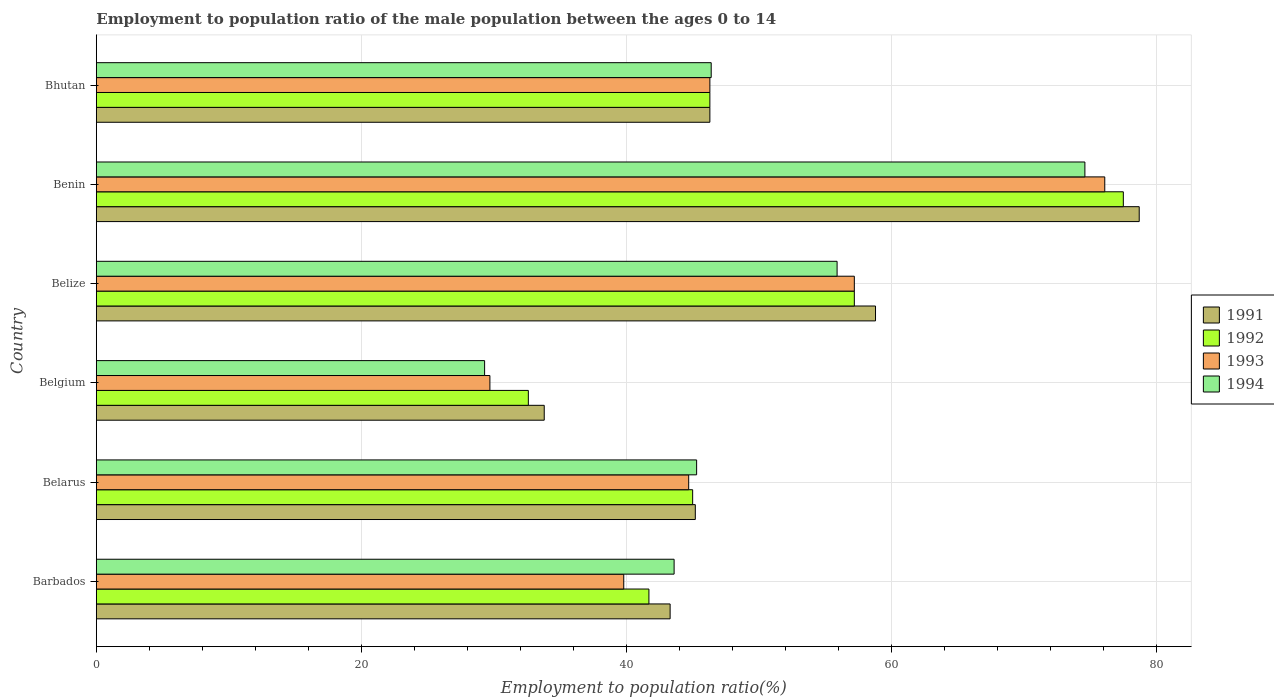Are the number of bars per tick equal to the number of legend labels?
Your response must be concise. Yes. Are the number of bars on each tick of the Y-axis equal?
Offer a terse response. Yes. How many bars are there on the 4th tick from the bottom?
Keep it short and to the point. 4. What is the label of the 2nd group of bars from the top?
Provide a succinct answer. Benin. What is the employment to population ratio in 1991 in Belgium?
Offer a very short reply. 33.8. Across all countries, what is the maximum employment to population ratio in 1992?
Your response must be concise. 77.5. Across all countries, what is the minimum employment to population ratio in 1994?
Keep it short and to the point. 29.3. In which country was the employment to population ratio in 1991 maximum?
Keep it short and to the point. Benin. In which country was the employment to population ratio in 1994 minimum?
Your answer should be compact. Belgium. What is the total employment to population ratio in 1994 in the graph?
Provide a succinct answer. 295.1. What is the difference between the employment to population ratio in 1993 in Barbados and that in Benin?
Your answer should be compact. -36.3. What is the difference between the employment to population ratio in 1992 in Belarus and the employment to population ratio in 1991 in Barbados?
Offer a terse response. 1.7. What is the average employment to population ratio in 1992 per country?
Provide a short and direct response. 50.05. What is the difference between the employment to population ratio in 1991 and employment to population ratio in 1993 in Benin?
Provide a succinct answer. 2.6. In how many countries, is the employment to population ratio in 1992 greater than 52 %?
Provide a short and direct response. 2. What is the ratio of the employment to population ratio in 1992 in Belgium to that in Belize?
Ensure brevity in your answer.  0.57. Is the employment to population ratio in 1991 in Belgium less than that in Benin?
Your answer should be very brief. Yes. Is the difference between the employment to population ratio in 1991 in Barbados and Belgium greater than the difference between the employment to population ratio in 1993 in Barbados and Belgium?
Keep it short and to the point. No. What is the difference between the highest and the second highest employment to population ratio in 1993?
Ensure brevity in your answer.  18.9. What is the difference between the highest and the lowest employment to population ratio in 1994?
Give a very brief answer. 45.3. Is it the case that in every country, the sum of the employment to population ratio in 1992 and employment to population ratio in 1993 is greater than the sum of employment to population ratio in 1991 and employment to population ratio in 1994?
Make the answer very short. No. What does the 3rd bar from the top in Barbados represents?
Keep it short and to the point. 1992. What does the 3rd bar from the bottom in Barbados represents?
Give a very brief answer. 1993. Is it the case that in every country, the sum of the employment to population ratio in 1991 and employment to population ratio in 1993 is greater than the employment to population ratio in 1994?
Offer a terse response. Yes. Are all the bars in the graph horizontal?
Give a very brief answer. Yes. Does the graph contain grids?
Your answer should be very brief. Yes. Where does the legend appear in the graph?
Your response must be concise. Center right. What is the title of the graph?
Make the answer very short. Employment to population ratio of the male population between the ages 0 to 14. What is the label or title of the X-axis?
Your answer should be very brief. Employment to population ratio(%). What is the label or title of the Y-axis?
Provide a succinct answer. Country. What is the Employment to population ratio(%) of 1991 in Barbados?
Provide a short and direct response. 43.3. What is the Employment to population ratio(%) of 1992 in Barbados?
Your answer should be very brief. 41.7. What is the Employment to population ratio(%) in 1993 in Barbados?
Make the answer very short. 39.8. What is the Employment to population ratio(%) in 1994 in Barbados?
Your answer should be very brief. 43.6. What is the Employment to population ratio(%) of 1991 in Belarus?
Keep it short and to the point. 45.2. What is the Employment to population ratio(%) in 1993 in Belarus?
Ensure brevity in your answer.  44.7. What is the Employment to population ratio(%) in 1994 in Belarus?
Provide a succinct answer. 45.3. What is the Employment to population ratio(%) of 1991 in Belgium?
Your answer should be compact. 33.8. What is the Employment to population ratio(%) of 1992 in Belgium?
Your response must be concise. 32.6. What is the Employment to population ratio(%) of 1993 in Belgium?
Make the answer very short. 29.7. What is the Employment to population ratio(%) of 1994 in Belgium?
Provide a short and direct response. 29.3. What is the Employment to population ratio(%) in 1991 in Belize?
Your answer should be very brief. 58.8. What is the Employment to population ratio(%) of 1992 in Belize?
Keep it short and to the point. 57.2. What is the Employment to population ratio(%) of 1993 in Belize?
Offer a terse response. 57.2. What is the Employment to population ratio(%) of 1994 in Belize?
Ensure brevity in your answer.  55.9. What is the Employment to population ratio(%) of 1991 in Benin?
Offer a very short reply. 78.7. What is the Employment to population ratio(%) of 1992 in Benin?
Ensure brevity in your answer.  77.5. What is the Employment to population ratio(%) in 1993 in Benin?
Your response must be concise. 76.1. What is the Employment to population ratio(%) in 1994 in Benin?
Keep it short and to the point. 74.6. What is the Employment to population ratio(%) of 1991 in Bhutan?
Your response must be concise. 46.3. What is the Employment to population ratio(%) of 1992 in Bhutan?
Provide a succinct answer. 46.3. What is the Employment to population ratio(%) of 1993 in Bhutan?
Provide a succinct answer. 46.3. What is the Employment to population ratio(%) of 1994 in Bhutan?
Offer a very short reply. 46.4. Across all countries, what is the maximum Employment to population ratio(%) of 1991?
Your response must be concise. 78.7. Across all countries, what is the maximum Employment to population ratio(%) of 1992?
Your answer should be compact. 77.5. Across all countries, what is the maximum Employment to population ratio(%) of 1993?
Offer a very short reply. 76.1. Across all countries, what is the maximum Employment to population ratio(%) in 1994?
Provide a succinct answer. 74.6. Across all countries, what is the minimum Employment to population ratio(%) in 1991?
Ensure brevity in your answer.  33.8. Across all countries, what is the minimum Employment to population ratio(%) of 1992?
Keep it short and to the point. 32.6. Across all countries, what is the minimum Employment to population ratio(%) in 1993?
Give a very brief answer. 29.7. Across all countries, what is the minimum Employment to population ratio(%) of 1994?
Make the answer very short. 29.3. What is the total Employment to population ratio(%) of 1991 in the graph?
Provide a succinct answer. 306.1. What is the total Employment to population ratio(%) in 1992 in the graph?
Provide a succinct answer. 300.3. What is the total Employment to population ratio(%) of 1993 in the graph?
Give a very brief answer. 293.8. What is the total Employment to population ratio(%) in 1994 in the graph?
Provide a succinct answer. 295.1. What is the difference between the Employment to population ratio(%) in 1991 in Barbados and that in Belarus?
Provide a succinct answer. -1.9. What is the difference between the Employment to population ratio(%) in 1993 in Barbados and that in Belarus?
Your response must be concise. -4.9. What is the difference between the Employment to population ratio(%) in 1994 in Barbados and that in Belarus?
Your response must be concise. -1.7. What is the difference between the Employment to population ratio(%) in 1992 in Barbados and that in Belgium?
Give a very brief answer. 9.1. What is the difference between the Employment to population ratio(%) in 1991 in Barbados and that in Belize?
Offer a terse response. -15.5. What is the difference between the Employment to population ratio(%) of 1992 in Barbados and that in Belize?
Provide a short and direct response. -15.5. What is the difference between the Employment to population ratio(%) of 1993 in Barbados and that in Belize?
Keep it short and to the point. -17.4. What is the difference between the Employment to population ratio(%) in 1991 in Barbados and that in Benin?
Offer a terse response. -35.4. What is the difference between the Employment to population ratio(%) in 1992 in Barbados and that in Benin?
Make the answer very short. -35.8. What is the difference between the Employment to population ratio(%) of 1993 in Barbados and that in Benin?
Offer a terse response. -36.3. What is the difference between the Employment to population ratio(%) of 1994 in Barbados and that in Benin?
Provide a succinct answer. -31. What is the difference between the Employment to population ratio(%) of 1991 in Barbados and that in Bhutan?
Your response must be concise. -3. What is the difference between the Employment to population ratio(%) in 1993 in Barbados and that in Bhutan?
Your answer should be compact. -6.5. What is the difference between the Employment to population ratio(%) of 1994 in Barbados and that in Bhutan?
Give a very brief answer. -2.8. What is the difference between the Employment to population ratio(%) in 1991 in Belarus and that in Belgium?
Make the answer very short. 11.4. What is the difference between the Employment to population ratio(%) of 1994 in Belarus and that in Belgium?
Your answer should be very brief. 16. What is the difference between the Employment to population ratio(%) of 1991 in Belarus and that in Belize?
Your response must be concise. -13.6. What is the difference between the Employment to population ratio(%) of 1993 in Belarus and that in Belize?
Make the answer very short. -12.5. What is the difference between the Employment to population ratio(%) in 1991 in Belarus and that in Benin?
Provide a short and direct response. -33.5. What is the difference between the Employment to population ratio(%) of 1992 in Belarus and that in Benin?
Offer a very short reply. -32.5. What is the difference between the Employment to population ratio(%) of 1993 in Belarus and that in Benin?
Make the answer very short. -31.4. What is the difference between the Employment to population ratio(%) of 1994 in Belarus and that in Benin?
Make the answer very short. -29.3. What is the difference between the Employment to population ratio(%) in 1991 in Belarus and that in Bhutan?
Your answer should be compact. -1.1. What is the difference between the Employment to population ratio(%) in 1993 in Belarus and that in Bhutan?
Provide a short and direct response. -1.6. What is the difference between the Employment to population ratio(%) of 1994 in Belarus and that in Bhutan?
Ensure brevity in your answer.  -1.1. What is the difference between the Employment to population ratio(%) of 1992 in Belgium and that in Belize?
Offer a terse response. -24.6. What is the difference between the Employment to population ratio(%) in 1993 in Belgium and that in Belize?
Give a very brief answer. -27.5. What is the difference between the Employment to population ratio(%) in 1994 in Belgium and that in Belize?
Keep it short and to the point. -26.6. What is the difference between the Employment to population ratio(%) of 1991 in Belgium and that in Benin?
Provide a succinct answer. -44.9. What is the difference between the Employment to population ratio(%) of 1992 in Belgium and that in Benin?
Provide a succinct answer. -44.9. What is the difference between the Employment to population ratio(%) of 1993 in Belgium and that in Benin?
Provide a short and direct response. -46.4. What is the difference between the Employment to population ratio(%) of 1994 in Belgium and that in Benin?
Provide a succinct answer. -45.3. What is the difference between the Employment to population ratio(%) in 1992 in Belgium and that in Bhutan?
Offer a very short reply. -13.7. What is the difference between the Employment to population ratio(%) in 1993 in Belgium and that in Bhutan?
Ensure brevity in your answer.  -16.6. What is the difference between the Employment to population ratio(%) of 1994 in Belgium and that in Bhutan?
Your response must be concise. -17.1. What is the difference between the Employment to population ratio(%) in 1991 in Belize and that in Benin?
Give a very brief answer. -19.9. What is the difference between the Employment to population ratio(%) in 1992 in Belize and that in Benin?
Make the answer very short. -20.3. What is the difference between the Employment to population ratio(%) of 1993 in Belize and that in Benin?
Make the answer very short. -18.9. What is the difference between the Employment to population ratio(%) of 1994 in Belize and that in Benin?
Keep it short and to the point. -18.7. What is the difference between the Employment to population ratio(%) of 1991 in Belize and that in Bhutan?
Ensure brevity in your answer.  12.5. What is the difference between the Employment to population ratio(%) in 1992 in Belize and that in Bhutan?
Give a very brief answer. 10.9. What is the difference between the Employment to population ratio(%) of 1994 in Belize and that in Bhutan?
Keep it short and to the point. 9.5. What is the difference between the Employment to population ratio(%) of 1991 in Benin and that in Bhutan?
Provide a short and direct response. 32.4. What is the difference between the Employment to population ratio(%) of 1992 in Benin and that in Bhutan?
Provide a short and direct response. 31.2. What is the difference between the Employment to population ratio(%) in 1993 in Benin and that in Bhutan?
Keep it short and to the point. 29.8. What is the difference between the Employment to population ratio(%) of 1994 in Benin and that in Bhutan?
Your answer should be very brief. 28.2. What is the difference between the Employment to population ratio(%) in 1991 in Barbados and the Employment to population ratio(%) in 1992 in Belarus?
Ensure brevity in your answer.  -1.7. What is the difference between the Employment to population ratio(%) in 1991 in Barbados and the Employment to population ratio(%) in 1994 in Belarus?
Keep it short and to the point. -2. What is the difference between the Employment to population ratio(%) in 1993 in Barbados and the Employment to population ratio(%) in 1994 in Belarus?
Your answer should be very brief. -5.5. What is the difference between the Employment to population ratio(%) of 1992 in Barbados and the Employment to population ratio(%) of 1994 in Belgium?
Ensure brevity in your answer.  12.4. What is the difference between the Employment to population ratio(%) of 1991 in Barbados and the Employment to population ratio(%) of 1992 in Belize?
Your answer should be very brief. -13.9. What is the difference between the Employment to population ratio(%) in 1991 in Barbados and the Employment to population ratio(%) in 1994 in Belize?
Give a very brief answer. -12.6. What is the difference between the Employment to population ratio(%) of 1992 in Barbados and the Employment to population ratio(%) of 1993 in Belize?
Your answer should be very brief. -15.5. What is the difference between the Employment to population ratio(%) in 1992 in Barbados and the Employment to population ratio(%) in 1994 in Belize?
Ensure brevity in your answer.  -14.2. What is the difference between the Employment to population ratio(%) in 1993 in Barbados and the Employment to population ratio(%) in 1994 in Belize?
Give a very brief answer. -16.1. What is the difference between the Employment to population ratio(%) in 1991 in Barbados and the Employment to population ratio(%) in 1992 in Benin?
Ensure brevity in your answer.  -34.2. What is the difference between the Employment to population ratio(%) in 1991 in Barbados and the Employment to population ratio(%) in 1993 in Benin?
Provide a succinct answer. -32.8. What is the difference between the Employment to population ratio(%) in 1991 in Barbados and the Employment to population ratio(%) in 1994 in Benin?
Give a very brief answer. -31.3. What is the difference between the Employment to population ratio(%) in 1992 in Barbados and the Employment to population ratio(%) in 1993 in Benin?
Offer a terse response. -34.4. What is the difference between the Employment to population ratio(%) in 1992 in Barbados and the Employment to population ratio(%) in 1994 in Benin?
Provide a short and direct response. -32.9. What is the difference between the Employment to population ratio(%) in 1993 in Barbados and the Employment to population ratio(%) in 1994 in Benin?
Your answer should be very brief. -34.8. What is the difference between the Employment to population ratio(%) in 1991 in Barbados and the Employment to population ratio(%) in 1992 in Bhutan?
Your answer should be very brief. -3. What is the difference between the Employment to population ratio(%) of 1991 in Barbados and the Employment to population ratio(%) of 1993 in Bhutan?
Keep it short and to the point. -3. What is the difference between the Employment to population ratio(%) in 1991 in Belarus and the Employment to population ratio(%) in 1993 in Belgium?
Ensure brevity in your answer.  15.5. What is the difference between the Employment to population ratio(%) of 1991 in Belarus and the Employment to population ratio(%) of 1994 in Belgium?
Offer a terse response. 15.9. What is the difference between the Employment to population ratio(%) in 1991 in Belarus and the Employment to population ratio(%) in 1993 in Belize?
Offer a very short reply. -12. What is the difference between the Employment to population ratio(%) in 1991 in Belarus and the Employment to population ratio(%) in 1994 in Belize?
Offer a terse response. -10.7. What is the difference between the Employment to population ratio(%) in 1992 in Belarus and the Employment to population ratio(%) in 1993 in Belize?
Ensure brevity in your answer.  -12.2. What is the difference between the Employment to population ratio(%) of 1992 in Belarus and the Employment to population ratio(%) of 1994 in Belize?
Keep it short and to the point. -10.9. What is the difference between the Employment to population ratio(%) of 1991 in Belarus and the Employment to population ratio(%) of 1992 in Benin?
Provide a succinct answer. -32.3. What is the difference between the Employment to population ratio(%) in 1991 in Belarus and the Employment to population ratio(%) in 1993 in Benin?
Your answer should be very brief. -30.9. What is the difference between the Employment to population ratio(%) in 1991 in Belarus and the Employment to population ratio(%) in 1994 in Benin?
Your answer should be very brief. -29.4. What is the difference between the Employment to population ratio(%) of 1992 in Belarus and the Employment to population ratio(%) of 1993 in Benin?
Make the answer very short. -31.1. What is the difference between the Employment to population ratio(%) of 1992 in Belarus and the Employment to population ratio(%) of 1994 in Benin?
Provide a short and direct response. -29.6. What is the difference between the Employment to population ratio(%) of 1993 in Belarus and the Employment to population ratio(%) of 1994 in Benin?
Offer a very short reply. -29.9. What is the difference between the Employment to population ratio(%) in 1991 in Belarus and the Employment to population ratio(%) in 1994 in Bhutan?
Make the answer very short. -1.2. What is the difference between the Employment to population ratio(%) of 1992 in Belarus and the Employment to population ratio(%) of 1994 in Bhutan?
Make the answer very short. -1.4. What is the difference between the Employment to population ratio(%) of 1993 in Belarus and the Employment to population ratio(%) of 1994 in Bhutan?
Make the answer very short. -1.7. What is the difference between the Employment to population ratio(%) in 1991 in Belgium and the Employment to population ratio(%) in 1992 in Belize?
Make the answer very short. -23.4. What is the difference between the Employment to population ratio(%) of 1991 in Belgium and the Employment to population ratio(%) of 1993 in Belize?
Provide a short and direct response. -23.4. What is the difference between the Employment to population ratio(%) in 1991 in Belgium and the Employment to population ratio(%) in 1994 in Belize?
Provide a short and direct response. -22.1. What is the difference between the Employment to population ratio(%) in 1992 in Belgium and the Employment to population ratio(%) in 1993 in Belize?
Offer a very short reply. -24.6. What is the difference between the Employment to population ratio(%) of 1992 in Belgium and the Employment to population ratio(%) of 1994 in Belize?
Give a very brief answer. -23.3. What is the difference between the Employment to population ratio(%) of 1993 in Belgium and the Employment to population ratio(%) of 1994 in Belize?
Offer a terse response. -26.2. What is the difference between the Employment to population ratio(%) in 1991 in Belgium and the Employment to population ratio(%) in 1992 in Benin?
Your answer should be very brief. -43.7. What is the difference between the Employment to population ratio(%) of 1991 in Belgium and the Employment to population ratio(%) of 1993 in Benin?
Make the answer very short. -42.3. What is the difference between the Employment to population ratio(%) of 1991 in Belgium and the Employment to population ratio(%) of 1994 in Benin?
Provide a succinct answer. -40.8. What is the difference between the Employment to population ratio(%) of 1992 in Belgium and the Employment to population ratio(%) of 1993 in Benin?
Your answer should be very brief. -43.5. What is the difference between the Employment to population ratio(%) of 1992 in Belgium and the Employment to population ratio(%) of 1994 in Benin?
Make the answer very short. -42. What is the difference between the Employment to population ratio(%) of 1993 in Belgium and the Employment to population ratio(%) of 1994 in Benin?
Your answer should be compact. -44.9. What is the difference between the Employment to population ratio(%) in 1991 in Belgium and the Employment to population ratio(%) in 1992 in Bhutan?
Make the answer very short. -12.5. What is the difference between the Employment to population ratio(%) of 1991 in Belgium and the Employment to population ratio(%) of 1993 in Bhutan?
Your answer should be very brief. -12.5. What is the difference between the Employment to population ratio(%) in 1991 in Belgium and the Employment to population ratio(%) in 1994 in Bhutan?
Provide a short and direct response. -12.6. What is the difference between the Employment to population ratio(%) in 1992 in Belgium and the Employment to population ratio(%) in 1993 in Bhutan?
Give a very brief answer. -13.7. What is the difference between the Employment to population ratio(%) in 1992 in Belgium and the Employment to population ratio(%) in 1994 in Bhutan?
Keep it short and to the point. -13.8. What is the difference between the Employment to population ratio(%) of 1993 in Belgium and the Employment to population ratio(%) of 1994 in Bhutan?
Your answer should be compact. -16.7. What is the difference between the Employment to population ratio(%) in 1991 in Belize and the Employment to population ratio(%) in 1992 in Benin?
Give a very brief answer. -18.7. What is the difference between the Employment to population ratio(%) of 1991 in Belize and the Employment to population ratio(%) of 1993 in Benin?
Make the answer very short. -17.3. What is the difference between the Employment to population ratio(%) in 1991 in Belize and the Employment to population ratio(%) in 1994 in Benin?
Offer a terse response. -15.8. What is the difference between the Employment to population ratio(%) in 1992 in Belize and the Employment to population ratio(%) in 1993 in Benin?
Give a very brief answer. -18.9. What is the difference between the Employment to population ratio(%) of 1992 in Belize and the Employment to population ratio(%) of 1994 in Benin?
Your answer should be very brief. -17.4. What is the difference between the Employment to population ratio(%) of 1993 in Belize and the Employment to population ratio(%) of 1994 in Benin?
Make the answer very short. -17.4. What is the difference between the Employment to population ratio(%) in 1991 in Belize and the Employment to population ratio(%) in 1992 in Bhutan?
Offer a terse response. 12.5. What is the difference between the Employment to population ratio(%) in 1991 in Benin and the Employment to population ratio(%) in 1992 in Bhutan?
Your answer should be very brief. 32.4. What is the difference between the Employment to population ratio(%) in 1991 in Benin and the Employment to population ratio(%) in 1993 in Bhutan?
Your response must be concise. 32.4. What is the difference between the Employment to population ratio(%) in 1991 in Benin and the Employment to population ratio(%) in 1994 in Bhutan?
Keep it short and to the point. 32.3. What is the difference between the Employment to population ratio(%) in 1992 in Benin and the Employment to population ratio(%) in 1993 in Bhutan?
Provide a short and direct response. 31.2. What is the difference between the Employment to population ratio(%) of 1992 in Benin and the Employment to population ratio(%) of 1994 in Bhutan?
Provide a succinct answer. 31.1. What is the difference between the Employment to population ratio(%) of 1993 in Benin and the Employment to population ratio(%) of 1994 in Bhutan?
Offer a terse response. 29.7. What is the average Employment to population ratio(%) in 1991 per country?
Provide a succinct answer. 51.02. What is the average Employment to population ratio(%) in 1992 per country?
Keep it short and to the point. 50.05. What is the average Employment to population ratio(%) of 1993 per country?
Provide a short and direct response. 48.97. What is the average Employment to population ratio(%) of 1994 per country?
Make the answer very short. 49.18. What is the difference between the Employment to population ratio(%) of 1991 and Employment to population ratio(%) of 1993 in Barbados?
Your response must be concise. 3.5. What is the difference between the Employment to population ratio(%) in 1993 and Employment to population ratio(%) in 1994 in Barbados?
Ensure brevity in your answer.  -3.8. What is the difference between the Employment to population ratio(%) of 1991 and Employment to population ratio(%) of 1992 in Belarus?
Ensure brevity in your answer.  0.2. What is the difference between the Employment to population ratio(%) in 1991 and Employment to population ratio(%) in 1993 in Belarus?
Ensure brevity in your answer.  0.5. What is the difference between the Employment to population ratio(%) of 1991 and Employment to population ratio(%) of 1994 in Belarus?
Give a very brief answer. -0.1. What is the difference between the Employment to population ratio(%) of 1992 and Employment to population ratio(%) of 1993 in Belarus?
Give a very brief answer. 0.3. What is the difference between the Employment to population ratio(%) in 1992 and Employment to population ratio(%) in 1994 in Belarus?
Provide a succinct answer. -0.3. What is the difference between the Employment to population ratio(%) of 1993 and Employment to population ratio(%) of 1994 in Belarus?
Provide a short and direct response. -0.6. What is the difference between the Employment to population ratio(%) in 1991 and Employment to population ratio(%) in 1993 in Belgium?
Provide a succinct answer. 4.1. What is the difference between the Employment to population ratio(%) in 1992 and Employment to population ratio(%) in 1994 in Belgium?
Ensure brevity in your answer.  3.3. What is the difference between the Employment to population ratio(%) in 1993 and Employment to population ratio(%) in 1994 in Belgium?
Provide a short and direct response. 0.4. What is the difference between the Employment to population ratio(%) of 1991 and Employment to population ratio(%) of 1993 in Belize?
Keep it short and to the point. 1.6. What is the difference between the Employment to population ratio(%) of 1991 and Employment to population ratio(%) of 1994 in Belize?
Provide a short and direct response. 2.9. What is the difference between the Employment to population ratio(%) in 1992 and Employment to population ratio(%) in 1994 in Belize?
Provide a short and direct response. 1.3. What is the difference between the Employment to population ratio(%) in 1993 and Employment to population ratio(%) in 1994 in Belize?
Provide a succinct answer. 1.3. What is the difference between the Employment to population ratio(%) of 1992 and Employment to population ratio(%) of 1993 in Bhutan?
Ensure brevity in your answer.  0. What is the difference between the Employment to population ratio(%) of 1992 and Employment to population ratio(%) of 1994 in Bhutan?
Offer a terse response. -0.1. What is the ratio of the Employment to population ratio(%) in 1991 in Barbados to that in Belarus?
Your response must be concise. 0.96. What is the ratio of the Employment to population ratio(%) of 1992 in Barbados to that in Belarus?
Offer a very short reply. 0.93. What is the ratio of the Employment to population ratio(%) in 1993 in Barbados to that in Belarus?
Offer a very short reply. 0.89. What is the ratio of the Employment to population ratio(%) in 1994 in Barbados to that in Belarus?
Keep it short and to the point. 0.96. What is the ratio of the Employment to population ratio(%) in 1991 in Barbados to that in Belgium?
Your answer should be very brief. 1.28. What is the ratio of the Employment to population ratio(%) of 1992 in Barbados to that in Belgium?
Keep it short and to the point. 1.28. What is the ratio of the Employment to population ratio(%) in 1993 in Barbados to that in Belgium?
Make the answer very short. 1.34. What is the ratio of the Employment to population ratio(%) of 1994 in Barbados to that in Belgium?
Your response must be concise. 1.49. What is the ratio of the Employment to population ratio(%) of 1991 in Barbados to that in Belize?
Ensure brevity in your answer.  0.74. What is the ratio of the Employment to population ratio(%) of 1992 in Barbados to that in Belize?
Make the answer very short. 0.73. What is the ratio of the Employment to population ratio(%) in 1993 in Barbados to that in Belize?
Provide a succinct answer. 0.7. What is the ratio of the Employment to population ratio(%) of 1994 in Barbados to that in Belize?
Your response must be concise. 0.78. What is the ratio of the Employment to population ratio(%) in 1991 in Barbados to that in Benin?
Your response must be concise. 0.55. What is the ratio of the Employment to population ratio(%) of 1992 in Barbados to that in Benin?
Provide a short and direct response. 0.54. What is the ratio of the Employment to population ratio(%) in 1993 in Barbados to that in Benin?
Give a very brief answer. 0.52. What is the ratio of the Employment to population ratio(%) of 1994 in Barbados to that in Benin?
Your answer should be very brief. 0.58. What is the ratio of the Employment to population ratio(%) of 1991 in Barbados to that in Bhutan?
Your response must be concise. 0.94. What is the ratio of the Employment to population ratio(%) of 1992 in Barbados to that in Bhutan?
Ensure brevity in your answer.  0.9. What is the ratio of the Employment to population ratio(%) of 1993 in Barbados to that in Bhutan?
Ensure brevity in your answer.  0.86. What is the ratio of the Employment to population ratio(%) in 1994 in Barbados to that in Bhutan?
Your answer should be very brief. 0.94. What is the ratio of the Employment to population ratio(%) in 1991 in Belarus to that in Belgium?
Offer a terse response. 1.34. What is the ratio of the Employment to population ratio(%) in 1992 in Belarus to that in Belgium?
Provide a short and direct response. 1.38. What is the ratio of the Employment to population ratio(%) of 1993 in Belarus to that in Belgium?
Your answer should be compact. 1.51. What is the ratio of the Employment to population ratio(%) in 1994 in Belarus to that in Belgium?
Give a very brief answer. 1.55. What is the ratio of the Employment to population ratio(%) of 1991 in Belarus to that in Belize?
Ensure brevity in your answer.  0.77. What is the ratio of the Employment to population ratio(%) in 1992 in Belarus to that in Belize?
Provide a short and direct response. 0.79. What is the ratio of the Employment to population ratio(%) of 1993 in Belarus to that in Belize?
Provide a short and direct response. 0.78. What is the ratio of the Employment to population ratio(%) of 1994 in Belarus to that in Belize?
Offer a terse response. 0.81. What is the ratio of the Employment to population ratio(%) of 1991 in Belarus to that in Benin?
Your answer should be compact. 0.57. What is the ratio of the Employment to population ratio(%) in 1992 in Belarus to that in Benin?
Make the answer very short. 0.58. What is the ratio of the Employment to population ratio(%) in 1993 in Belarus to that in Benin?
Provide a short and direct response. 0.59. What is the ratio of the Employment to population ratio(%) of 1994 in Belarus to that in Benin?
Your answer should be very brief. 0.61. What is the ratio of the Employment to population ratio(%) in 1991 in Belarus to that in Bhutan?
Your answer should be compact. 0.98. What is the ratio of the Employment to population ratio(%) of 1992 in Belarus to that in Bhutan?
Keep it short and to the point. 0.97. What is the ratio of the Employment to population ratio(%) in 1993 in Belarus to that in Bhutan?
Provide a succinct answer. 0.97. What is the ratio of the Employment to population ratio(%) in 1994 in Belarus to that in Bhutan?
Make the answer very short. 0.98. What is the ratio of the Employment to population ratio(%) of 1991 in Belgium to that in Belize?
Make the answer very short. 0.57. What is the ratio of the Employment to population ratio(%) in 1992 in Belgium to that in Belize?
Your answer should be very brief. 0.57. What is the ratio of the Employment to population ratio(%) in 1993 in Belgium to that in Belize?
Your answer should be very brief. 0.52. What is the ratio of the Employment to population ratio(%) of 1994 in Belgium to that in Belize?
Your answer should be compact. 0.52. What is the ratio of the Employment to population ratio(%) in 1991 in Belgium to that in Benin?
Provide a succinct answer. 0.43. What is the ratio of the Employment to population ratio(%) of 1992 in Belgium to that in Benin?
Ensure brevity in your answer.  0.42. What is the ratio of the Employment to population ratio(%) of 1993 in Belgium to that in Benin?
Your answer should be very brief. 0.39. What is the ratio of the Employment to population ratio(%) of 1994 in Belgium to that in Benin?
Provide a succinct answer. 0.39. What is the ratio of the Employment to population ratio(%) of 1991 in Belgium to that in Bhutan?
Your answer should be very brief. 0.73. What is the ratio of the Employment to population ratio(%) in 1992 in Belgium to that in Bhutan?
Your response must be concise. 0.7. What is the ratio of the Employment to population ratio(%) in 1993 in Belgium to that in Bhutan?
Keep it short and to the point. 0.64. What is the ratio of the Employment to population ratio(%) in 1994 in Belgium to that in Bhutan?
Your response must be concise. 0.63. What is the ratio of the Employment to population ratio(%) in 1991 in Belize to that in Benin?
Offer a terse response. 0.75. What is the ratio of the Employment to population ratio(%) in 1992 in Belize to that in Benin?
Provide a succinct answer. 0.74. What is the ratio of the Employment to population ratio(%) of 1993 in Belize to that in Benin?
Offer a terse response. 0.75. What is the ratio of the Employment to population ratio(%) of 1994 in Belize to that in Benin?
Your answer should be very brief. 0.75. What is the ratio of the Employment to population ratio(%) in 1991 in Belize to that in Bhutan?
Ensure brevity in your answer.  1.27. What is the ratio of the Employment to population ratio(%) in 1992 in Belize to that in Bhutan?
Offer a terse response. 1.24. What is the ratio of the Employment to population ratio(%) in 1993 in Belize to that in Bhutan?
Provide a succinct answer. 1.24. What is the ratio of the Employment to population ratio(%) in 1994 in Belize to that in Bhutan?
Give a very brief answer. 1.2. What is the ratio of the Employment to population ratio(%) in 1991 in Benin to that in Bhutan?
Give a very brief answer. 1.7. What is the ratio of the Employment to population ratio(%) in 1992 in Benin to that in Bhutan?
Ensure brevity in your answer.  1.67. What is the ratio of the Employment to population ratio(%) in 1993 in Benin to that in Bhutan?
Give a very brief answer. 1.64. What is the ratio of the Employment to population ratio(%) of 1994 in Benin to that in Bhutan?
Offer a terse response. 1.61. What is the difference between the highest and the second highest Employment to population ratio(%) of 1992?
Offer a very short reply. 20.3. What is the difference between the highest and the lowest Employment to population ratio(%) in 1991?
Your answer should be very brief. 44.9. What is the difference between the highest and the lowest Employment to population ratio(%) in 1992?
Your response must be concise. 44.9. What is the difference between the highest and the lowest Employment to population ratio(%) of 1993?
Your response must be concise. 46.4. What is the difference between the highest and the lowest Employment to population ratio(%) in 1994?
Make the answer very short. 45.3. 